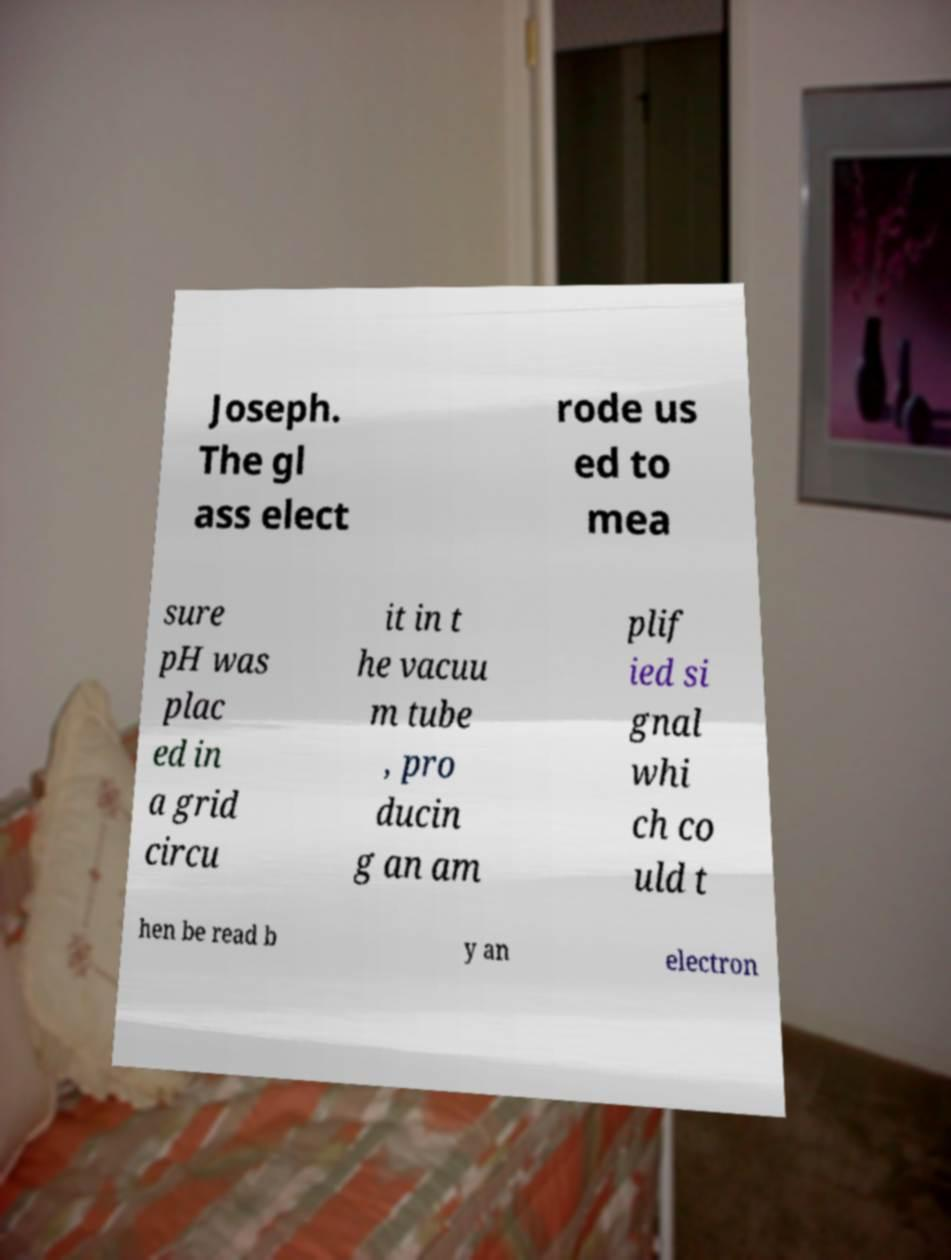There's text embedded in this image that I need extracted. Can you transcribe it verbatim? Joseph. The gl ass elect rode us ed to mea sure pH was plac ed in a grid circu it in t he vacuu m tube , pro ducin g an am plif ied si gnal whi ch co uld t hen be read b y an electron 